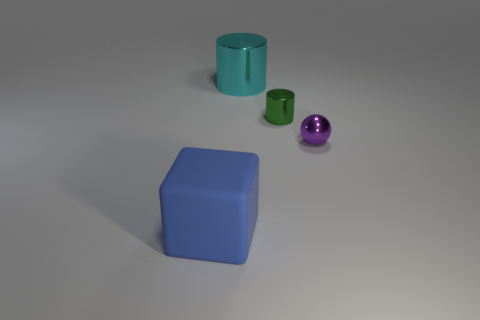Subtract 2 cylinders. How many cylinders are left? 0 Subtract all green cylinders. How many cylinders are left? 1 Add 3 small purple shiny spheres. How many small purple shiny spheres are left? 4 Add 2 tiny cylinders. How many tiny cylinders exist? 3 Add 3 small blue shiny objects. How many objects exist? 7 Subtract 0 purple cubes. How many objects are left? 4 Subtract all blocks. How many objects are left? 3 Subtract all yellow cubes. Subtract all cyan cylinders. How many cubes are left? 1 Subtract all big cyan metal cylinders. Subtract all cyan metal objects. How many objects are left? 2 